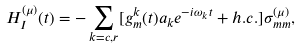Convert formula to latex. <formula><loc_0><loc_0><loc_500><loc_500>H _ { I } ^ { ( \mu ) } ( t ) = - \sum _ { k = c , r } [ g _ { m } ^ { k } ( t ) a _ { k } e ^ { - i \omega _ { k } t } + h . c . ] \sigma _ { m m } ^ { ( \mu ) } ,</formula> 